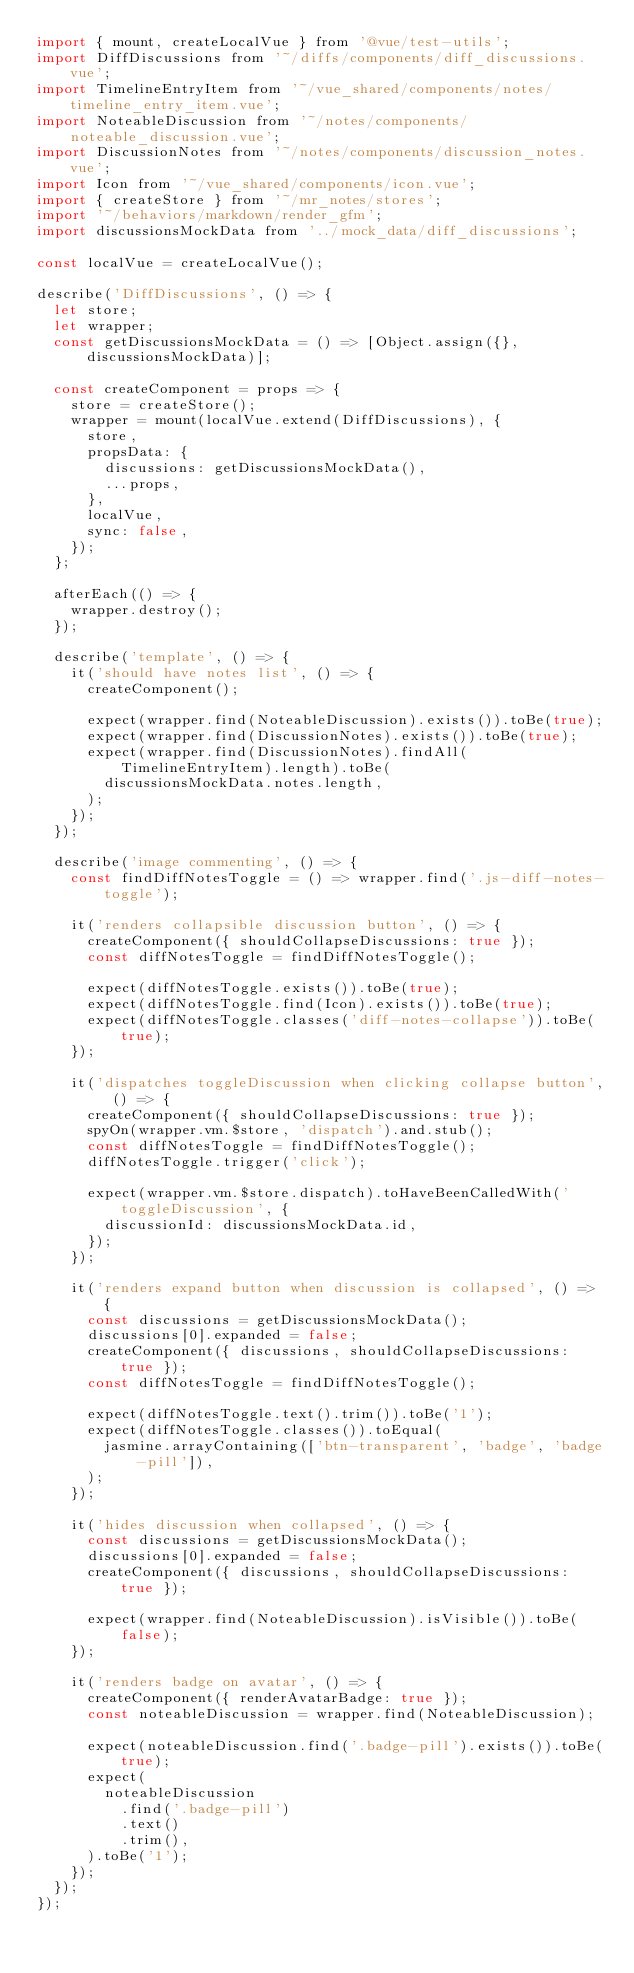Convert code to text. <code><loc_0><loc_0><loc_500><loc_500><_JavaScript_>import { mount, createLocalVue } from '@vue/test-utils';
import DiffDiscussions from '~/diffs/components/diff_discussions.vue';
import TimelineEntryItem from '~/vue_shared/components/notes/timeline_entry_item.vue';
import NoteableDiscussion from '~/notes/components/noteable_discussion.vue';
import DiscussionNotes from '~/notes/components/discussion_notes.vue';
import Icon from '~/vue_shared/components/icon.vue';
import { createStore } from '~/mr_notes/stores';
import '~/behaviors/markdown/render_gfm';
import discussionsMockData from '../mock_data/diff_discussions';

const localVue = createLocalVue();

describe('DiffDiscussions', () => {
  let store;
  let wrapper;
  const getDiscussionsMockData = () => [Object.assign({}, discussionsMockData)];

  const createComponent = props => {
    store = createStore();
    wrapper = mount(localVue.extend(DiffDiscussions), {
      store,
      propsData: {
        discussions: getDiscussionsMockData(),
        ...props,
      },
      localVue,
      sync: false,
    });
  };

  afterEach(() => {
    wrapper.destroy();
  });

  describe('template', () => {
    it('should have notes list', () => {
      createComponent();

      expect(wrapper.find(NoteableDiscussion).exists()).toBe(true);
      expect(wrapper.find(DiscussionNotes).exists()).toBe(true);
      expect(wrapper.find(DiscussionNotes).findAll(TimelineEntryItem).length).toBe(
        discussionsMockData.notes.length,
      );
    });
  });

  describe('image commenting', () => {
    const findDiffNotesToggle = () => wrapper.find('.js-diff-notes-toggle');

    it('renders collapsible discussion button', () => {
      createComponent({ shouldCollapseDiscussions: true });
      const diffNotesToggle = findDiffNotesToggle();

      expect(diffNotesToggle.exists()).toBe(true);
      expect(diffNotesToggle.find(Icon).exists()).toBe(true);
      expect(diffNotesToggle.classes('diff-notes-collapse')).toBe(true);
    });

    it('dispatches toggleDiscussion when clicking collapse button', () => {
      createComponent({ shouldCollapseDiscussions: true });
      spyOn(wrapper.vm.$store, 'dispatch').and.stub();
      const diffNotesToggle = findDiffNotesToggle();
      diffNotesToggle.trigger('click');

      expect(wrapper.vm.$store.dispatch).toHaveBeenCalledWith('toggleDiscussion', {
        discussionId: discussionsMockData.id,
      });
    });

    it('renders expand button when discussion is collapsed', () => {
      const discussions = getDiscussionsMockData();
      discussions[0].expanded = false;
      createComponent({ discussions, shouldCollapseDiscussions: true });
      const diffNotesToggle = findDiffNotesToggle();

      expect(diffNotesToggle.text().trim()).toBe('1');
      expect(diffNotesToggle.classes()).toEqual(
        jasmine.arrayContaining(['btn-transparent', 'badge', 'badge-pill']),
      );
    });

    it('hides discussion when collapsed', () => {
      const discussions = getDiscussionsMockData();
      discussions[0].expanded = false;
      createComponent({ discussions, shouldCollapseDiscussions: true });

      expect(wrapper.find(NoteableDiscussion).isVisible()).toBe(false);
    });

    it('renders badge on avatar', () => {
      createComponent({ renderAvatarBadge: true });
      const noteableDiscussion = wrapper.find(NoteableDiscussion);

      expect(noteableDiscussion.find('.badge-pill').exists()).toBe(true);
      expect(
        noteableDiscussion
          .find('.badge-pill')
          .text()
          .trim(),
      ).toBe('1');
    });
  });
});
</code> 